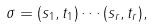Convert formula to latex. <formula><loc_0><loc_0><loc_500><loc_500>\sigma = ( s _ { 1 } , t _ { 1 } ) \cdots ( s _ { r } , t _ { r } ) ,</formula> 